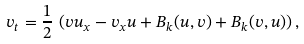<formula> <loc_0><loc_0><loc_500><loc_500>v _ { t } = \frac { 1 } { 2 } \, \left ( v u _ { x } - v _ { x } u + B _ { k } ( u , v ) + B _ { k } ( v , u ) \right ) ,</formula> 